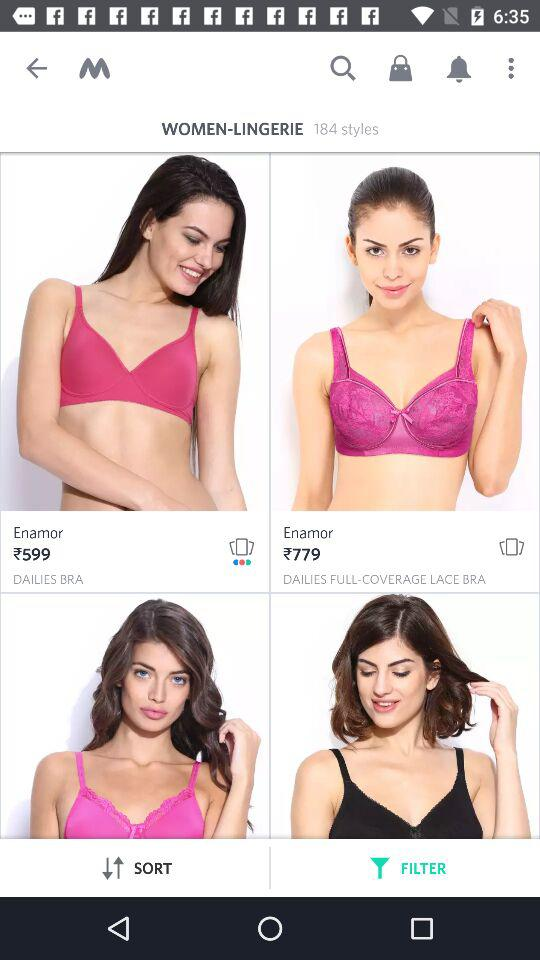Which tab is selected? The selected tab is "FILTER". 